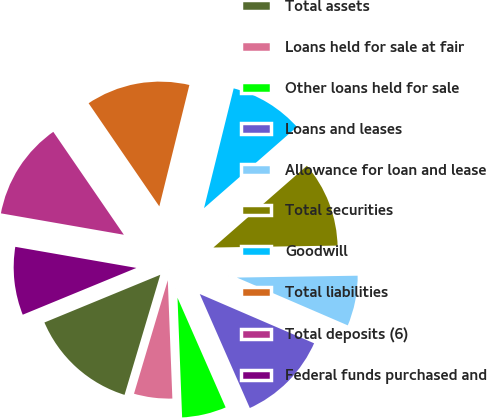Convert chart to OTSL. <chart><loc_0><loc_0><loc_500><loc_500><pie_chart><fcel>Total assets<fcel>Loans held for sale at fair<fcel>Other loans held for sale<fcel>Loans and leases<fcel>Allowance for loan and lease<fcel>Total securities<fcel>Goodwill<fcel>Total liabilities<fcel>Total deposits (6)<fcel>Federal funds purchased and<nl><fcel>14.18%<fcel>5.22%<fcel>5.97%<fcel>11.94%<fcel>6.72%<fcel>11.19%<fcel>9.7%<fcel>13.43%<fcel>12.69%<fcel>8.96%<nl></chart> 